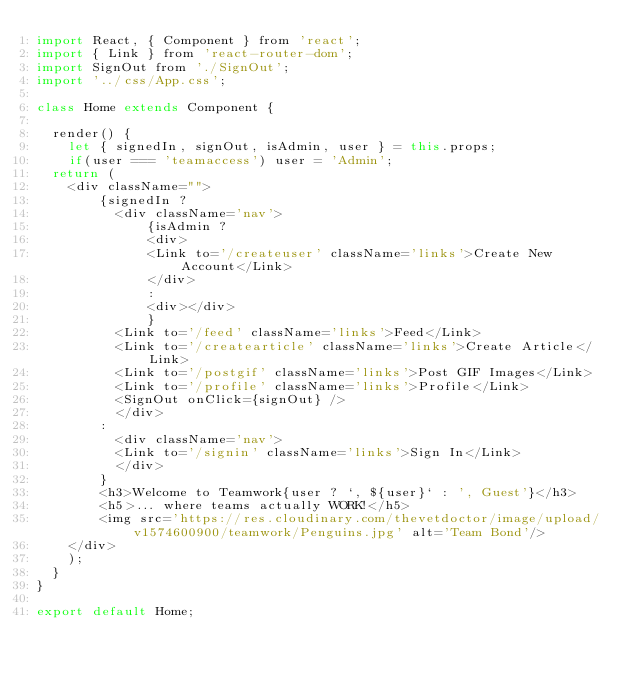Convert code to text. <code><loc_0><loc_0><loc_500><loc_500><_JavaScript_>import React, { Component } from 'react';
import { Link } from 'react-router-dom';
import SignOut from './SignOut';
import '../css/App.css';

class Home extends Component {

  render() {
    let { signedIn, signOut, isAdmin, user } = this.props;
    if(user === 'teamaccess') user = 'Admin';
  return (
    <div className="">
        {signedIn ?
          <div className='nav'>
              {isAdmin ?
              <div>
              <Link to='/createuser' className='links'>Create New Account</Link>
              </div>
              :
              <div></div>
              }
          <Link to='/feed' className='links'>Feed</Link>
          <Link to='/createarticle' className='links'>Create Article</Link>
          <Link to='/postgif' className='links'>Post GIF Images</Link>
          <Link to='/profile' className='links'>Profile</Link>
          <SignOut onClick={signOut} />
          </div>
        :
          <div className='nav'>
          <Link to='/signin' className='links'>Sign In</Link>
          </div>
        }
        <h3>Welcome to Teamwork{user ? `, ${user}` : ', Guest'}</h3>
        <h5>... where teams actually WORK!</h5>
        <img src='https://res.cloudinary.com/thevetdoctor/image/upload/v1574600900/teamwork/Penguins.jpg' alt='Team Bond'/>
    </div>
    );
  }
}

export default Home;
</code> 